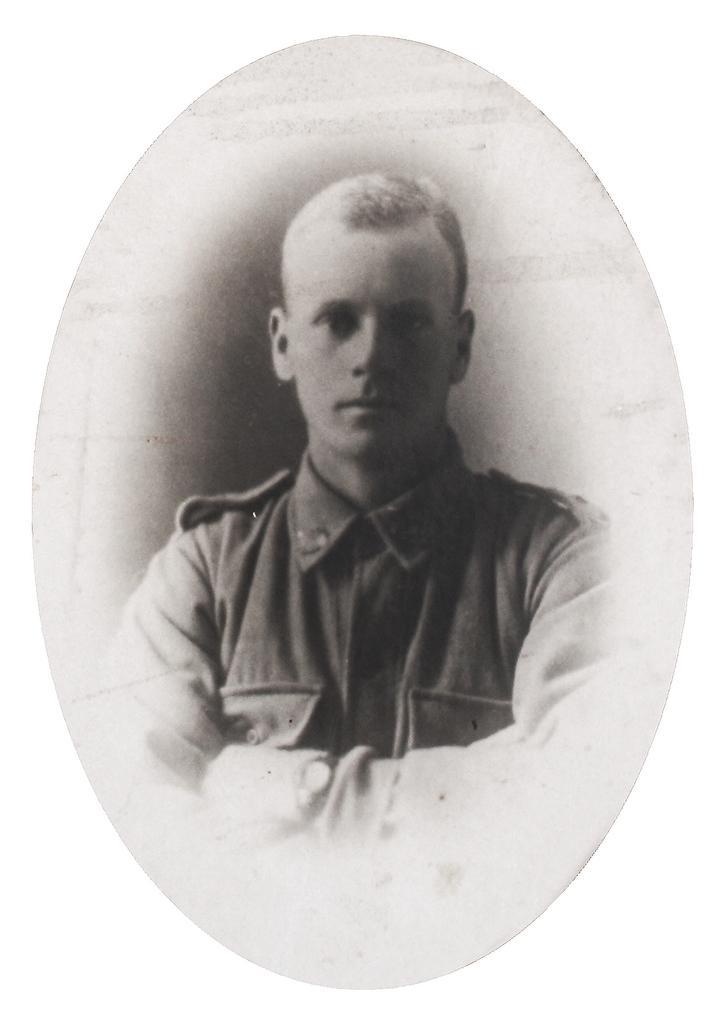How would you summarize this image in a sentence or two? In this image, we can see the poster of a person. 